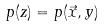Convert formula to latex. <formula><loc_0><loc_0><loc_500><loc_500>p ( z ) = p ( \vec { x } , y )</formula> 